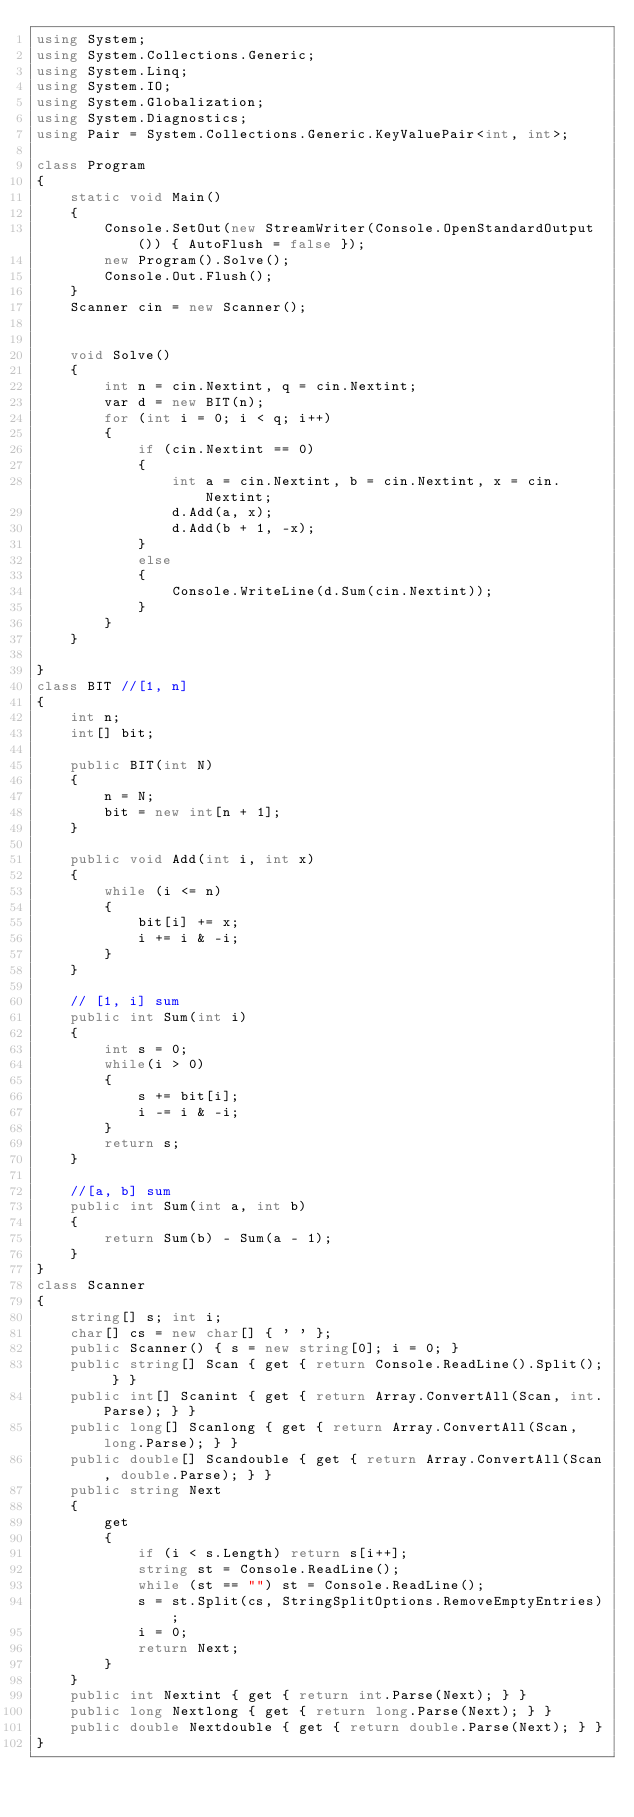Convert code to text. <code><loc_0><loc_0><loc_500><loc_500><_C#_>using System;
using System.Collections.Generic;
using System.Linq;
using System.IO;
using System.Globalization;
using System.Diagnostics;
using Pair = System.Collections.Generic.KeyValuePair<int, int>;

class Program
{
    static void Main()
    {
        Console.SetOut(new StreamWriter(Console.OpenStandardOutput()) { AutoFlush = false });
        new Program().Solve();
        Console.Out.Flush();
    }
    Scanner cin = new Scanner();


    void Solve()
    {
        int n = cin.Nextint, q = cin.Nextint;
        var d = new BIT(n);
        for (int i = 0; i < q; i++)
        {
            if (cin.Nextint == 0)
            {
                int a = cin.Nextint, b = cin.Nextint, x = cin.Nextint;
                d.Add(a, x);
                d.Add(b + 1, -x);
            }
            else
            {
                Console.WriteLine(d.Sum(cin.Nextint));
            }
        }
    }

}
class BIT //[1, n]
{
    int n;
    int[] bit;

    public BIT(int N)
    {
        n = N;
        bit = new int[n + 1];
    }

    public void Add(int i, int x)
    {
        while (i <= n)
        {
            bit[i] += x;
            i += i & -i;
        }
    }

    // [1, i] sum
    public int Sum(int i)
    {
        int s = 0;
        while(i > 0)
        {
            s += bit[i];
            i -= i & -i;
        }
        return s;
    }

    //[a, b] sum
    public int Sum(int a, int b)
    {
        return Sum(b) - Sum(a - 1);
    }
}
class Scanner
{
    string[] s; int i;
    char[] cs = new char[] { ' ' };
    public Scanner() { s = new string[0]; i = 0; }
    public string[] Scan { get { return Console.ReadLine().Split(); } }
    public int[] Scanint { get { return Array.ConvertAll(Scan, int.Parse); } }
    public long[] Scanlong { get { return Array.ConvertAll(Scan, long.Parse); } }
    public double[] Scandouble { get { return Array.ConvertAll(Scan, double.Parse); } }
    public string Next
    {
        get
        {
            if (i < s.Length) return s[i++];
            string st = Console.ReadLine();
            while (st == "") st = Console.ReadLine();
            s = st.Split(cs, StringSplitOptions.RemoveEmptyEntries);
            i = 0;
            return Next;
        }
    }
    public int Nextint { get { return int.Parse(Next); } }
    public long Nextlong { get { return long.Parse(Next); } }
    public double Nextdouble { get { return double.Parse(Next); } }
}</code> 